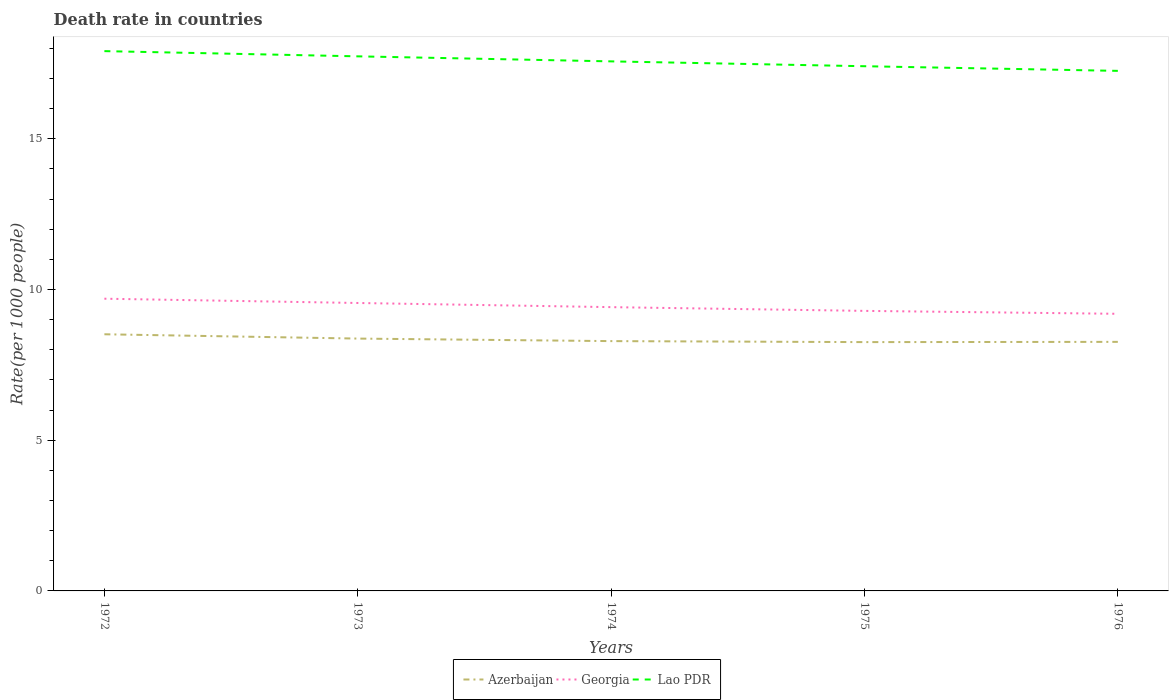Does the line corresponding to Georgia intersect with the line corresponding to Azerbaijan?
Provide a succinct answer. No. Is the number of lines equal to the number of legend labels?
Your answer should be compact. Yes. Across all years, what is the maximum death rate in Georgia?
Your answer should be compact. 9.2. In which year was the death rate in Lao PDR maximum?
Offer a very short reply. 1976. What is the total death rate in Georgia in the graph?
Give a very brief answer. 0.1. What is the difference between the highest and the second highest death rate in Azerbaijan?
Your answer should be compact. 0.26. What is the difference between the highest and the lowest death rate in Lao PDR?
Give a very brief answer. 2. Are the values on the major ticks of Y-axis written in scientific E-notation?
Make the answer very short. No. Does the graph contain any zero values?
Provide a succinct answer. No. Does the graph contain grids?
Your answer should be compact. No. How many legend labels are there?
Offer a terse response. 3. How are the legend labels stacked?
Offer a terse response. Horizontal. What is the title of the graph?
Ensure brevity in your answer.  Death rate in countries. What is the label or title of the X-axis?
Keep it short and to the point. Years. What is the label or title of the Y-axis?
Keep it short and to the point. Rate(per 1000 people). What is the Rate(per 1000 people) in Azerbaijan in 1972?
Ensure brevity in your answer.  8.52. What is the Rate(per 1000 people) of Georgia in 1972?
Offer a terse response. 9.7. What is the Rate(per 1000 people) in Lao PDR in 1972?
Provide a short and direct response. 17.91. What is the Rate(per 1000 people) in Azerbaijan in 1973?
Ensure brevity in your answer.  8.37. What is the Rate(per 1000 people) of Georgia in 1973?
Offer a very short reply. 9.55. What is the Rate(per 1000 people) of Lao PDR in 1973?
Keep it short and to the point. 17.74. What is the Rate(per 1000 people) of Azerbaijan in 1974?
Provide a short and direct response. 8.29. What is the Rate(per 1000 people) in Georgia in 1974?
Provide a short and direct response. 9.42. What is the Rate(per 1000 people) of Lao PDR in 1974?
Your response must be concise. 17.57. What is the Rate(per 1000 people) of Azerbaijan in 1975?
Your answer should be compact. 8.26. What is the Rate(per 1000 people) of Georgia in 1975?
Offer a very short reply. 9.29. What is the Rate(per 1000 people) of Lao PDR in 1975?
Your answer should be very brief. 17.41. What is the Rate(per 1000 people) in Azerbaijan in 1976?
Your answer should be very brief. 8.26. What is the Rate(per 1000 people) of Georgia in 1976?
Your response must be concise. 9.2. What is the Rate(per 1000 people) of Lao PDR in 1976?
Your response must be concise. 17.26. Across all years, what is the maximum Rate(per 1000 people) in Azerbaijan?
Your answer should be very brief. 8.52. Across all years, what is the maximum Rate(per 1000 people) of Georgia?
Offer a terse response. 9.7. Across all years, what is the maximum Rate(per 1000 people) of Lao PDR?
Offer a terse response. 17.91. Across all years, what is the minimum Rate(per 1000 people) in Azerbaijan?
Ensure brevity in your answer.  8.26. Across all years, what is the minimum Rate(per 1000 people) of Georgia?
Your answer should be compact. 9.2. Across all years, what is the minimum Rate(per 1000 people) in Lao PDR?
Your answer should be very brief. 17.26. What is the total Rate(per 1000 people) in Azerbaijan in the graph?
Your response must be concise. 41.7. What is the total Rate(per 1000 people) in Georgia in the graph?
Your answer should be compact. 47.15. What is the total Rate(per 1000 people) in Lao PDR in the graph?
Ensure brevity in your answer.  87.89. What is the difference between the Rate(per 1000 people) in Azerbaijan in 1972 and that in 1973?
Ensure brevity in your answer.  0.14. What is the difference between the Rate(per 1000 people) in Georgia in 1972 and that in 1973?
Provide a succinct answer. 0.14. What is the difference between the Rate(per 1000 people) in Lao PDR in 1972 and that in 1973?
Offer a very short reply. 0.17. What is the difference between the Rate(per 1000 people) in Azerbaijan in 1972 and that in 1974?
Keep it short and to the point. 0.23. What is the difference between the Rate(per 1000 people) in Georgia in 1972 and that in 1974?
Offer a terse response. 0.28. What is the difference between the Rate(per 1000 people) of Lao PDR in 1972 and that in 1974?
Your response must be concise. 0.34. What is the difference between the Rate(per 1000 people) in Azerbaijan in 1972 and that in 1975?
Offer a very short reply. 0.26. What is the difference between the Rate(per 1000 people) in Georgia in 1972 and that in 1975?
Provide a succinct answer. 0.4. What is the difference between the Rate(per 1000 people) of Lao PDR in 1972 and that in 1975?
Offer a terse response. 0.5. What is the difference between the Rate(per 1000 people) in Azerbaijan in 1972 and that in 1976?
Provide a succinct answer. 0.25. What is the difference between the Rate(per 1000 people) in Georgia in 1972 and that in 1976?
Your answer should be compact. 0.5. What is the difference between the Rate(per 1000 people) in Lao PDR in 1972 and that in 1976?
Your response must be concise. 0.66. What is the difference between the Rate(per 1000 people) of Azerbaijan in 1973 and that in 1974?
Make the answer very short. 0.08. What is the difference between the Rate(per 1000 people) in Georgia in 1973 and that in 1974?
Offer a terse response. 0.14. What is the difference between the Rate(per 1000 people) in Lao PDR in 1973 and that in 1974?
Give a very brief answer. 0.17. What is the difference between the Rate(per 1000 people) of Azerbaijan in 1973 and that in 1975?
Your answer should be compact. 0.12. What is the difference between the Rate(per 1000 people) of Georgia in 1973 and that in 1975?
Give a very brief answer. 0.26. What is the difference between the Rate(per 1000 people) of Lao PDR in 1973 and that in 1975?
Your answer should be compact. 0.33. What is the difference between the Rate(per 1000 people) of Azerbaijan in 1973 and that in 1976?
Provide a succinct answer. 0.11. What is the difference between the Rate(per 1000 people) in Georgia in 1973 and that in 1976?
Ensure brevity in your answer.  0.36. What is the difference between the Rate(per 1000 people) in Lao PDR in 1973 and that in 1976?
Your response must be concise. 0.48. What is the difference between the Rate(per 1000 people) in Azerbaijan in 1974 and that in 1975?
Ensure brevity in your answer.  0.03. What is the difference between the Rate(per 1000 people) of Georgia in 1974 and that in 1975?
Your answer should be compact. 0.12. What is the difference between the Rate(per 1000 people) in Lao PDR in 1974 and that in 1975?
Your response must be concise. 0.16. What is the difference between the Rate(per 1000 people) in Azerbaijan in 1974 and that in 1976?
Your answer should be compact. 0.03. What is the difference between the Rate(per 1000 people) in Georgia in 1974 and that in 1976?
Ensure brevity in your answer.  0.22. What is the difference between the Rate(per 1000 people) of Lao PDR in 1974 and that in 1976?
Give a very brief answer. 0.32. What is the difference between the Rate(per 1000 people) of Azerbaijan in 1975 and that in 1976?
Keep it short and to the point. -0.01. What is the difference between the Rate(per 1000 people) of Georgia in 1975 and that in 1976?
Ensure brevity in your answer.  0.1. What is the difference between the Rate(per 1000 people) in Lao PDR in 1975 and that in 1976?
Keep it short and to the point. 0.15. What is the difference between the Rate(per 1000 people) of Azerbaijan in 1972 and the Rate(per 1000 people) of Georgia in 1973?
Make the answer very short. -1.04. What is the difference between the Rate(per 1000 people) in Azerbaijan in 1972 and the Rate(per 1000 people) in Lao PDR in 1973?
Give a very brief answer. -9.22. What is the difference between the Rate(per 1000 people) in Georgia in 1972 and the Rate(per 1000 people) in Lao PDR in 1973?
Give a very brief answer. -8.04. What is the difference between the Rate(per 1000 people) of Azerbaijan in 1972 and the Rate(per 1000 people) of Georgia in 1974?
Offer a very short reply. -0.9. What is the difference between the Rate(per 1000 people) in Azerbaijan in 1972 and the Rate(per 1000 people) in Lao PDR in 1974?
Ensure brevity in your answer.  -9.05. What is the difference between the Rate(per 1000 people) of Georgia in 1972 and the Rate(per 1000 people) of Lao PDR in 1974?
Offer a very short reply. -7.88. What is the difference between the Rate(per 1000 people) in Azerbaijan in 1972 and the Rate(per 1000 people) in Georgia in 1975?
Your answer should be compact. -0.78. What is the difference between the Rate(per 1000 people) in Azerbaijan in 1972 and the Rate(per 1000 people) in Lao PDR in 1975?
Offer a terse response. -8.89. What is the difference between the Rate(per 1000 people) of Georgia in 1972 and the Rate(per 1000 people) of Lao PDR in 1975?
Your answer should be very brief. -7.71. What is the difference between the Rate(per 1000 people) of Azerbaijan in 1972 and the Rate(per 1000 people) of Georgia in 1976?
Give a very brief answer. -0.68. What is the difference between the Rate(per 1000 people) in Azerbaijan in 1972 and the Rate(per 1000 people) in Lao PDR in 1976?
Keep it short and to the point. -8.74. What is the difference between the Rate(per 1000 people) of Georgia in 1972 and the Rate(per 1000 people) of Lao PDR in 1976?
Make the answer very short. -7.56. What is the difference between the Rate(per 1000 people) of Azerbaijan in 1973 and the Rate(per 1000 people) of Georgia in 1974?
Offer a very short reply. -1.04. What is the difference between the Rate(per 1000 people) of Azerbaijan in 1973 and the Rate(per 1000 people) of Lao PDR in 1974?
Provide a succinct answer. -9.2. What is the difference between the Rate(per 1000 people) of Georgia in 1973 and the Rate(per 1000 people) of Lao PDR in 1974?
Give a very brief answer. -8.02. What is the difference between the Rate(per 1000 people) of Azerbaijan in 1973 and the Rate(per 1000 people) of Georgia in 1975?
Your answer should be compact. -0.92. What is the difference between the Rate(per 1000 people) in Azerbaijan in 1973 and the Rate(per 1000 people) in Lao PDR in 1975?
Offer a terse response. -9.04. What is the difference between the Rate(per 1000 people) in Georgia in 1973 and the Rate(per 1000 people) in Lao PDR in 1975?
Offer a very short reply. -7.86. What is the difference between the Rate(per 1000 people) in Azerbaijan in 1973 and the Rate(per 1000 people) in Georgia in 1976?
Offer a very short reply. -0.82. What is the difference between the Rate(per 1000 people) in Azerbaijan in 1973 and the Rate(per 1000 people) in Lao PDR in 1976?
Offer a very short reply. -8.88. What is the difference between the Rate(per 1000 people) in Georgia in 1973 and the Rate(per 1000 people) in Lao PDR in 1976?
Offer a very short reply. -7.7. What is the difference between the Rate(per 1000 people) in Azerbaijan in 1974 and the Rate(per 1000 people) in Georgia in 1975?
Keep it short and to the point. -1. What is the difference between the Rate(per 1000 people) of Azerbaijan in 1974 and the Rate(per 1000 people) of Lao PDR in 1975?
Your answer should be very brief. -9.12. What is the difference between the Rate(per 1000 people) in Georgia in 1974 and the Rate(per 1000 people) in Lao PDR in 1975?
Your answer should be compact. -7.99. What is the difference between the Rate(per 1000 people) of Azerbaijan in 1974 and the Rate(per 1000 people) of Georgia in 1976?
Your response must be concise. -0.91. What is the difference between the Rate(per 1000 people) of Azerbaijan in 1974 and the Rate(per 1000 people) of Lao PDR in 1976?
Make the answer very short. -8.97. What is the difference between the Rate(per 1000 people) of Georgia in 1974 and the Rate(per 1000 people) of Lao PDR in 1976?
Ensure brevity in your answer.  -7.84. What is the difference between the Rate(per 1000 people) of Azerbaijan in 1975 and the Rate(per 1000 people) of Georgia in 1976?
Your answer should be compact. -0.94. What is the difference between the Rate(per 1000 people) of Azerbaijan in 1975 and the Rate(per 1000 people) of Lao PDR in 1976?
Keep it short and to the point. -9. What is the difference between the Rate(per 1000 people) in Georgia in 1975 and the Rate(per 1000 people) in Lao PDR in 1976?
Your answer should be very brief. -7.96. What is the average Rate(per 1000 people) in Azerbaijan per year?
Your answer should be compact. 8.34. What is the average Rate(per 1000 people) of Georgia per year?
Ensure brevity in your answer.  9.43. What is the average Rate(per 1000 people) of Lao PDR per year?
Ensure brevity in your answer.  17.58. In the year 1972, what is the difference between the Rate(per 1000 people) of Azerbaijan and Rate(per 1000 people) of Georgia?
Provide a succinct answer. -1.18. In the year 1972, what is the difference between the Rate(per 1000 people) of Azerbaijan and Rate(per 1000 people) of Lao PDR?
Offer a terse response. -9.39. In the year 1972, what is the difference between the Rate(per 1000 people) in Georgia and Rate(per 1000 people) in Lao PDR?
Offer a terse response. -8.21. In the year 1973, what is the difference between the Rate(per 1000 people) in Azerbaijan and Rate(per 1000 people) in Georgia?
Keep it short and to the point. -1.18. In the year 1973, what is the difference between the Rate(per 1000 people) in Azerbaijan and Rate(per 1000 people) in Lao PDR?
Give a very brief answer. -9.37. In the year 1973, what is the difference between the Rate(per 1000 people) of Georgia and Rate(per 1000 people) of Lao PDR?
Give a very brief answer. -8.18. In the year 1974, what is the difference between the Rate(per 1000 people) of Azerbaijan and Rate(per 1000 people) of Georgia?
Keep it short and to the point. -1.13. In the year 1974, what is the difference between the Rate(per 1000 people) in Azerbaijan and Rate(per 1000 people) in Lao PDR?
Provide a short and direct response. -9.28. In the year 1974, what is the difference between the Rate(per 1000 people) of Georgia and Rate(per 1000 people) of Lao PDR?
Give a very brief answer. -8.15. In the year 1975, what is the difference between the Rate(per 1000 people) in Azerbaijan and Rate(per 1000 people) in Georgia?
Offer a very short reply. -1.04. In the year 1975, what is the difference between the Rate(per 1000 people) in Azerbaijan and Rate(per 1000 people) in Lao PDR?
Offer a very short reply. -9.15. In the year 1975, what is the difference between the Rate(per 1000 people) of Georgia and Rate(per 1000 people) of Lao PDR?
Your response must be concise. -8.12. In the year 1976, what is the difference between the Rate(per 1000 people) in Azerbaijan and Rate(per 1000 people) in Georgia?
Your answer should be compact. -0.93. In the year 1976, what is the difference between the Rate(per 1000 people) in Azerbaijan and Rate(per 1000 people) in Lao PDR?
Offer a terse response. -8.99. In the year 1976, what is the difference between the Rate(per 1000 people) of Georgia and Rate(per 1000 people) of Lao PDR?
Offer a terse response. -8.06. What is the ratio of the Rate(per 1000 people) in Azerbaijan in 1972 to that in 1973?
Offer a terse response. 1.02. What is the ratio of the Rate(per 1000 people) of Georgia in 1972 to that in 1973?
Give a very brief answer. 1.01. What is the ratio of the Rate(per 1000 people) of Lao PDR in 1972 to that in 1973?
Your answer should be compact. 1.01. What is the ratio of the Rate(per 1000 people) of Azerbaijan in 1972 to that in 1974?
Give a very brief answer. 1.03. What is the ratio of the Rate(per 1000 people) in Georgia in 1972 to that in 1974?
Ensure brevity in your answer.  1.03. What is the ratio of the Rate(per 1000 people) in Lao PDR in 1972 to that in 1974?
Your answer should be compact. 1.02. What is the ratio of the Rate(per 1000 people) of Azerbaijan in 1972 to that in 1975?
Provide a succinct answer. 1.03. What is the ratio of the Rate(per 1000 people) in Georgia in 1972 to that in 1975?
Your answer should be compact. 1.04. What is the ratio of the Rate(per 1000 people) of Lao PDR in 1972 to that in 1975?
Give a very brief answer. 1.03. What is the ratio of the Rate(per 1000 people) in Azerbaijan in 1972 to that in 1976?
Keep it short and to the point. 1.03. What is the ratio of the Rate(per 1000 people) of Georgia in 1972 to that in 1976?
Your response must be concise. 1.05. What is the ratio of the Rate(per 1000 people) in Lao PDR in 1972 to that in 1976?
Your answer should be compact. 1.04. What is the ratio of the Rate(per 1000 people) of Azerbaijan in 1973 to that in 1974?
Provide a succinct answer. 1.01. What is the ratio of the Rate(per 1000 people) in Georgia in 1973 to that in 1974?
Offer a very short reply. 1.01. What is the ratio of the Rate(per 1000 people) in Lao PDR in 1973 to that in 1974?
Provide a succinct answer. 1.01. What is the ratio of the Rate(per 1000 people) of Azerbaijan in 1973 to that in 1975?
Offer a terse response. 1.01. What is the ratio of the Rate(per 1000 people) in Georgia in 1973 to that in 1975?
Provide a short and direct response. 1.03. What is the ratio of the Rate(per 1000 people) of Lao PDR in 1973 to that in 1975?
Ensure brevity in your answer.  1.02. What is the ratio of the Rate(per 1000 people) of Azerbaijan in 1973 to that in 1976?
Ensure brevity in your answer.  1.01. What is the ratio of the Rate(per 1000 people) of Georgia in 1973 to that in 1976?
Your response must be concise. 1.04. What is the ratio of the Rate(per 1000 people) in Lao PDR in 1973 to that in 1976?
Make the answer very short. 1.03. What is the ratio of the Rate(per 1000 people) in Georgia in 1974 to that in 1975?
Offer a very short reply. 1.01. What is the ratio of the Rate(per 1000 people) in Lao PDR in 1974 to that in 1975?
Keep it short and to the point. 1.01. What is the ratio of the Rate(per 1000 people) of Lao PDR in 1974 to that in 1976?
Your response must be concise. 1.02. What is the ratio of the Rate(per 1000 people) of Azerbaijan in 1975 to that in 1976?
Keep it short and to the point. 1. What is the ratio of the Rate(per 1000 people) of Georgia in 1975 to that in 1976?
Your response must be concise. 1.01. What is the ratio of the Rate(per 1000 people) of Lao PDR in 1975 to that in 1976?
Provide a succinct answer. 1.01. What is the difference between the highest and the second highest Rate(per 1000 people) of Azerbaijan?
Provide a succinct answer. 0.14. What is the difference between the highest and the second highest Rate(per 1000 people) of Georgia?
Your response must be concise. 0.14. What is the difference between the highest and the second highest Rate(per 1000 people) in Lao PDR?
Offer a very short reply. 0.17. What is the difference between the highest and the lowest Rate(per 1000 people) of Azerbaijan?
Offer a terse response. 0.26. What is the difference between the highest and the lowest Rate(per 1000 people) in Georgia?
Offer a terse response. 0.5. What is the difference between the highest and the lowest Rate(per 1000 people) of Lao PDR?
Provide a short and direct response. 0.66. 